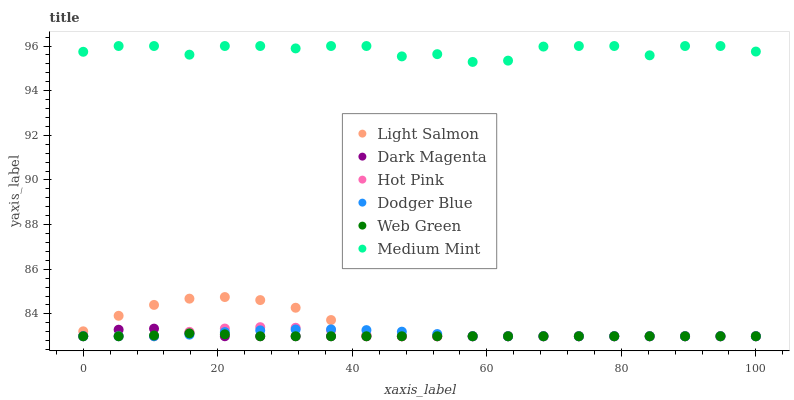Does Web Green have the minimum area under the curve?
Answer yes or no. Yes. Does Medium Mint have the maximum area under the curve?
Answer yes or no. Yes. Does Light Salmon have the minimum area under the curve?
Answer yes or no. No. Does Light Salmon have the maximum area under the curve?
Answer yes or no. No. Is Web Green the smoothest?
Answer yes or no. Yes. Is Medium Mint the roughest?
Answer yes or no. Yes. Is Light Salmon the smoothest?
Answer yes or no. No. Is Light Salmon the roughest?
Answer yes or no. No. Does Light Salmon have the lowest value?
Answer yes or no. Yes. Does Medium Mint have the highest value?
Answer yes or no. Yes. Does Light Salmon have the highest value?
Answer yes or no. No. Is Web Green less than Medium Mint?
Answer yes or no. Yes. Is Medium Mint greater than Dodger Blue?
Answer yes or no. Yes. Does Light Salmon intersect Web Green?
Answer yes or no. Yes. Is Light Salmon less than Web Green?
Answer yes or no. No. Is Light Salmon greater than Web Green?
Answer yes or no. No. Does Web Green intersect Medium Mint?
Answer yes or no. No. 